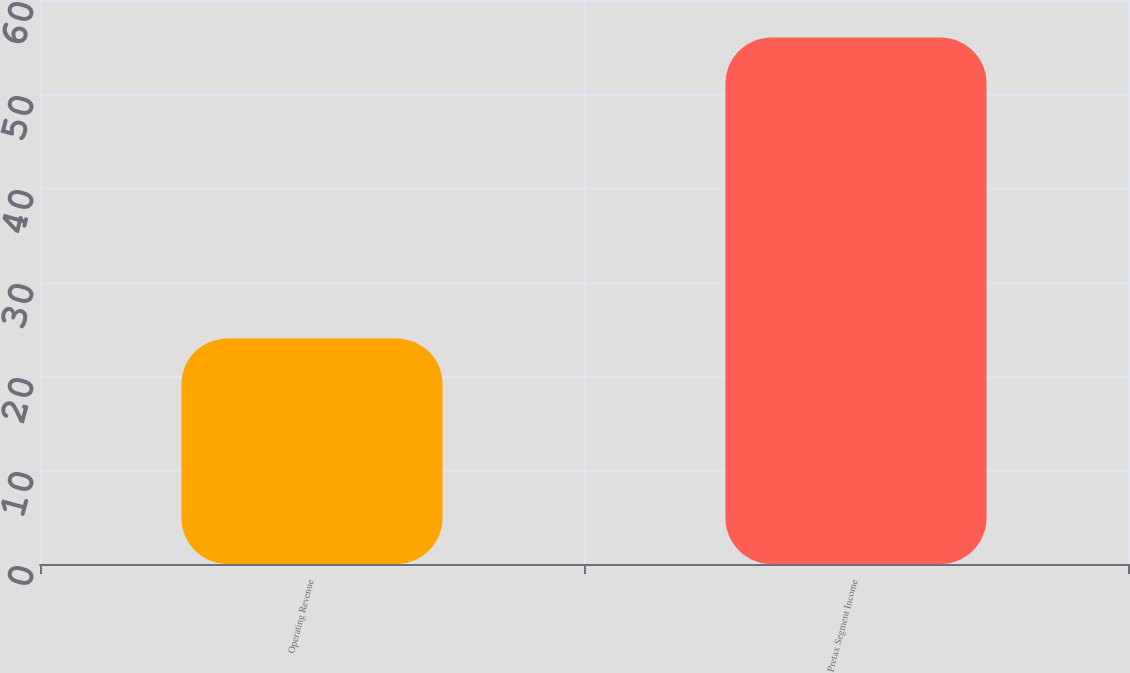Convert chart. <chart><loc_0><loc_0><loc_500><loc_500><bar_chart><fcel>Operating Revenue<fcel>Pretax Segment Income<nl><fcel>24<fcel>56<nl></chart> 